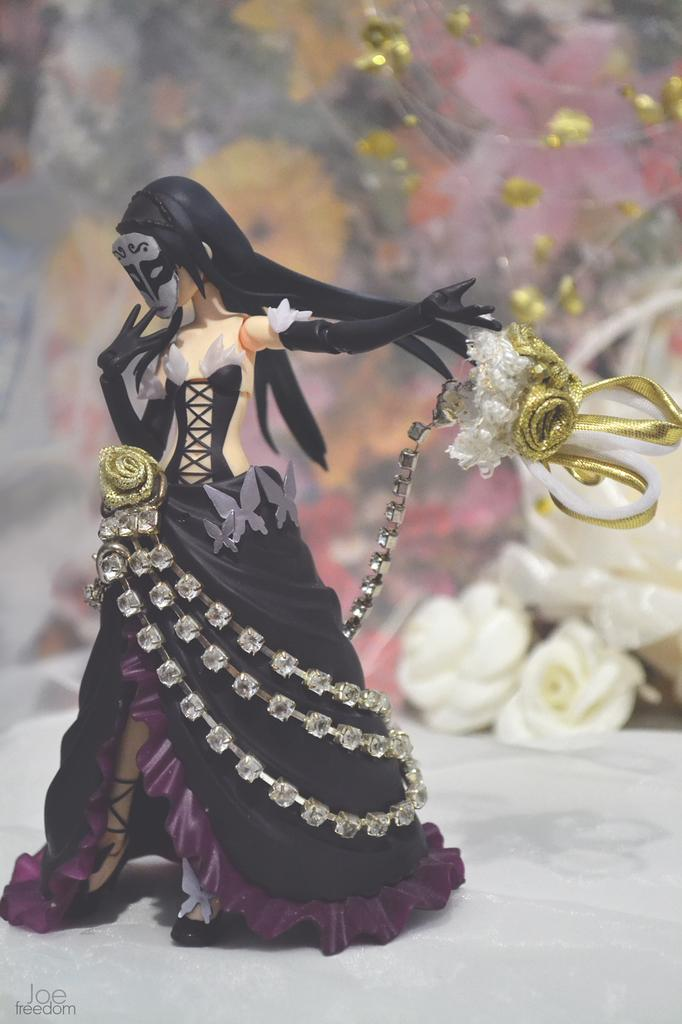What is the main subject in the center of the image? There is a toy in the center of the image. What can be seen in the background of the image? There are flowers visible in the background of the image. What type of ship can be seen sailing in harmony with the toy in the image? There is no ship present in the image, and the toy is not shown sailing in harmony with any other object. 